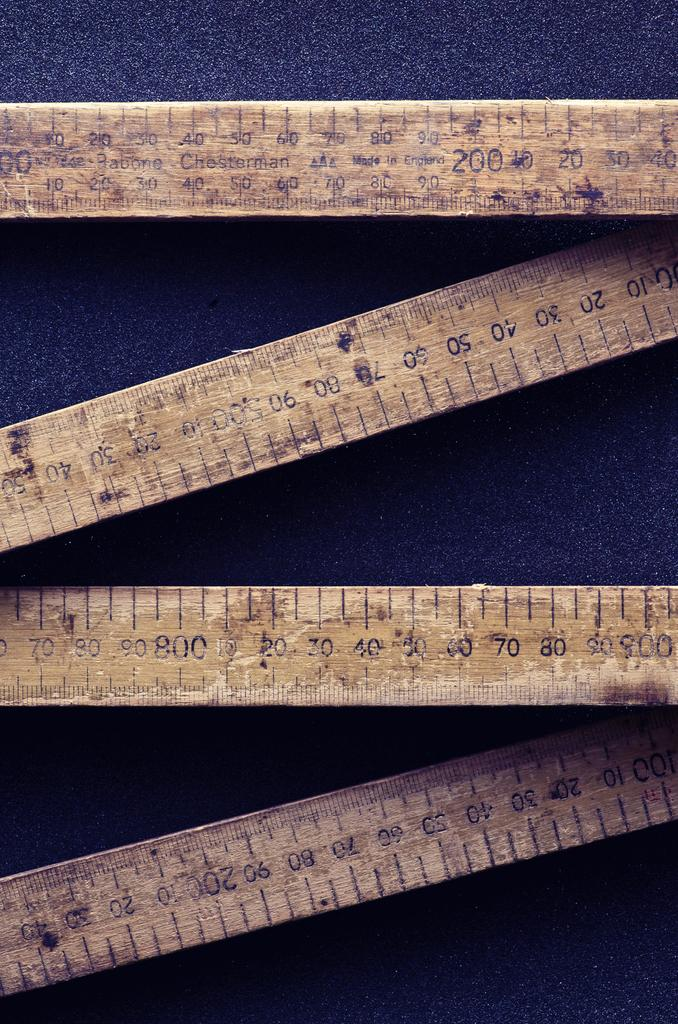What objects are present in the image? There are four wooden scales in the image. What is the wooden scales placed on? The wooden scales are placed on a blue color sheet. What type of skirt is hanging from the wooden scales in the image? There is no skirt present in the image; it only features four wooden scales placed on a blue color sheet. 